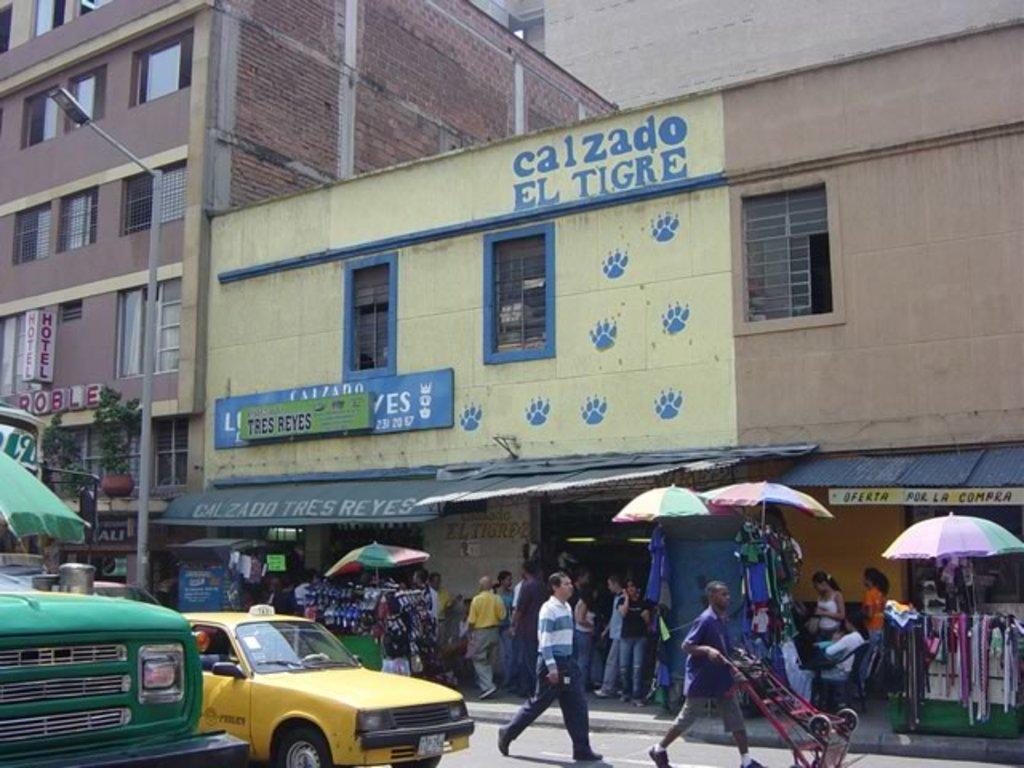What is the yellow establishment called?
Offer a very short reply. Calzado el tigre. What is written on the green sign?
Offer a terse response. Tres reyes. 